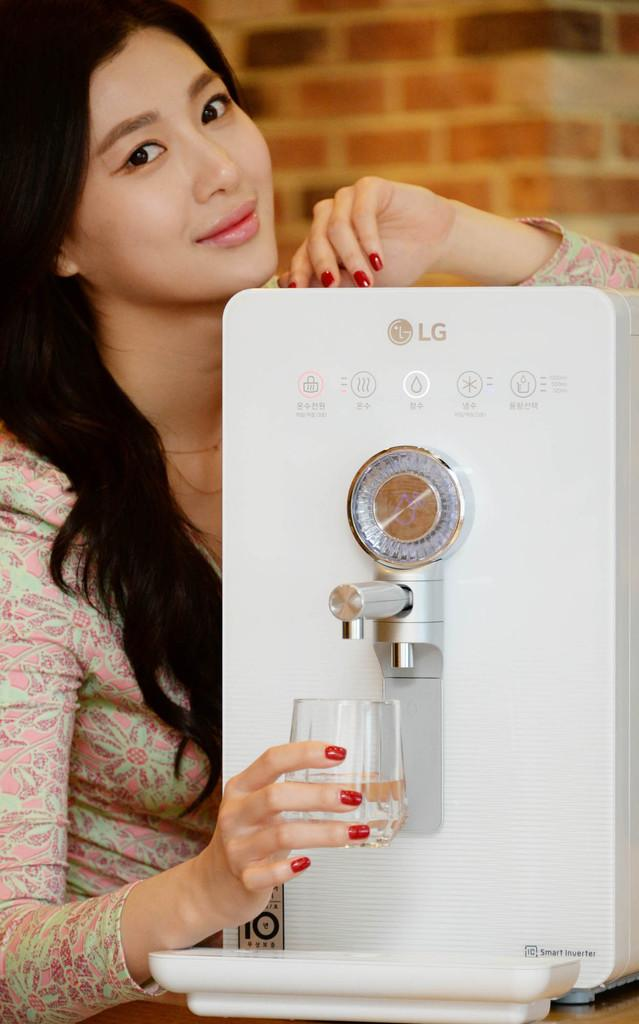Provide a one-sentence caption for the provided image. A woman is getting a glass of water from an LG water dispenser. 